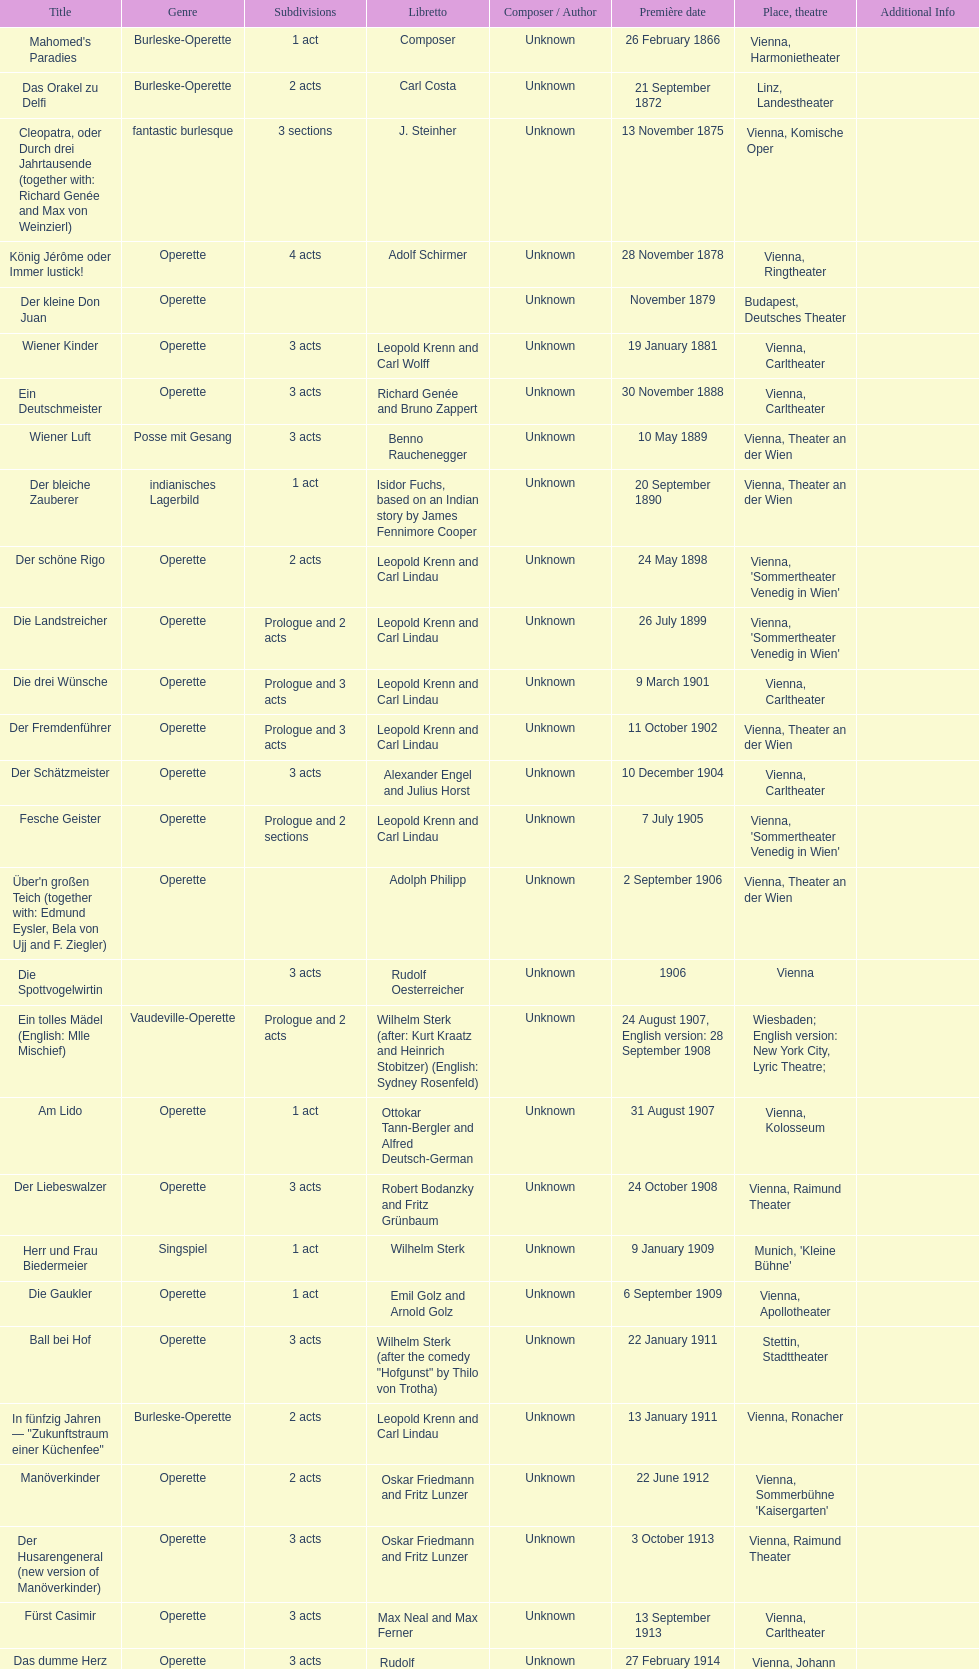How many number of 1 acts were there? 5. 